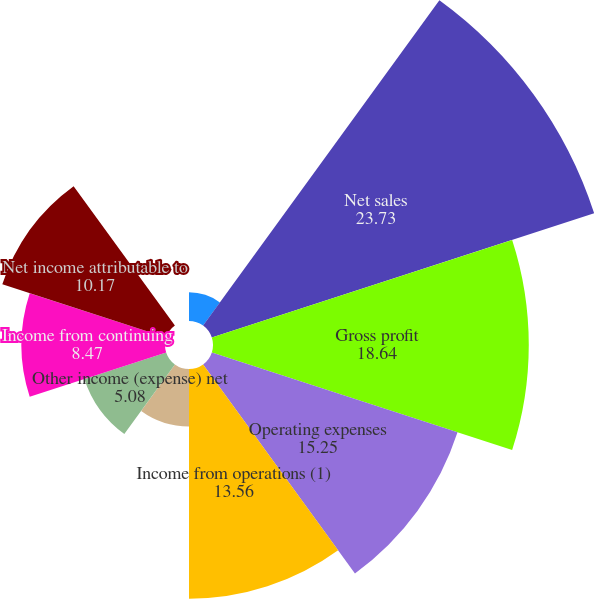Convert chart to OTSL. <chart><loc_0><loc_0><loc_500><loc_500><pie_chart><fcel>In thousands except per share<fcel>Net sales<fcel>Gross profit<fcel>Operating expenses<fcel>Income from operations (1)<fcel>Interest expense net<fcel>Other income (expense) net<fcel>Income from continuing<fcel>Net income attributable to<fcel>Cash dividends declared per<nl><fcel>1.69%<fcel>23.73%<fcel>18.64%<fcel>15.25%<fcel>13.56%<fcel>3.39%<fcel>5.08%<fcel>8.47%<fcel>10.17%<fcel>0.0%<nl></chart> 